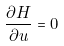Convert formula to latex. <formula><loc_0><loc_0><loc_500><loc_500>\frac { \partial H } { \partial u } = 0</formula> 